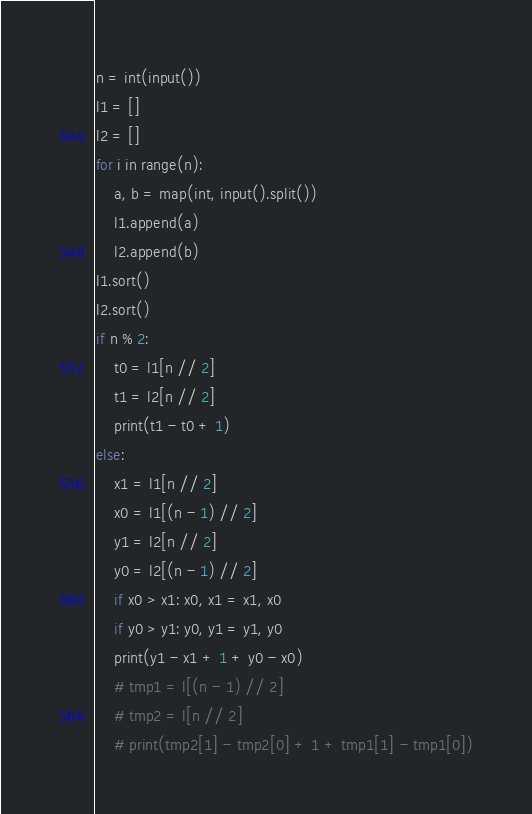<code> <loc_0><loc_0><loc_500><loc_500><_Python_>n = int(input())
l1 = []
l2 = []
for i in range(n):
    a, b = map(int, input().split())
    l1.append(a)
    l2.append(b)
l1.sort()
l2.sort()
if n % 2:
    t0 = l1[n // 2]
    t1 = l2[n // 2]
    print(t1 - t0 + 1)
else:
    x1 = l1[n // 2]
    x0 = l1[(n - 1) // 2]
    y1 = l2[n // 2]
    y0 = l2[(n - 1) // 2]
    if x0 > x1: x0, x1 = x1, x0
    if y0 > y1: y0, y1 = y1, y0
    print(y1 - x1 + 1 + y0 - x0)
    # tmp1 = l[(n - 1) // 2]
    # tmp2 = l[n // 2]
    # print(tmp2[1] - tmp2[0] + 1 + tmp1[1] - tmp1[0])</code> 